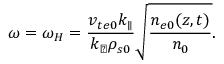Convert formula to latex. <formula><loc_0><loc_0><loc_500><loc_500>\omega = \omega _ { H } = \frac { v _ { t e 0 } k _ { \| } } { k _ { \perp } \rho _ { s 0 } } \sqrt { \frac { n _ { e 0 } ( z , t ) } { n _ { 0 } } } .</formula> 